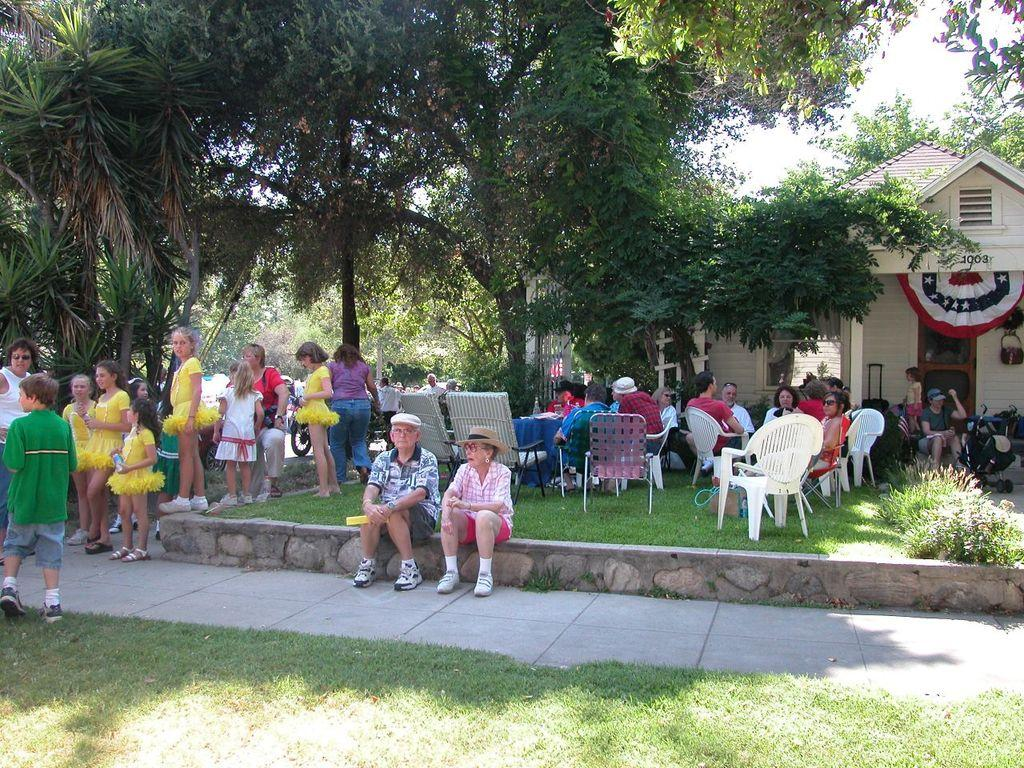What type of vegetation can be seen in the image? There are trees in the image. What type of structure is present in the image? There is a shed in the image. What are some people doing in the image? Some people are sitting and some are standing in the image. What type of seating is available in the image? There are chairs in the image. What is visible at the bottom of the image? There is grass at the bottom of the image. What can be seen in the background of the image? The sky is visible in the background of the image. How many scarves are being worn by the people in the image? There is no information about scarves in the image, so we cannot determine the amount. What type of trousers are the people wearing in the image? There is no information about the type of trousers being worn by the people in the image. 